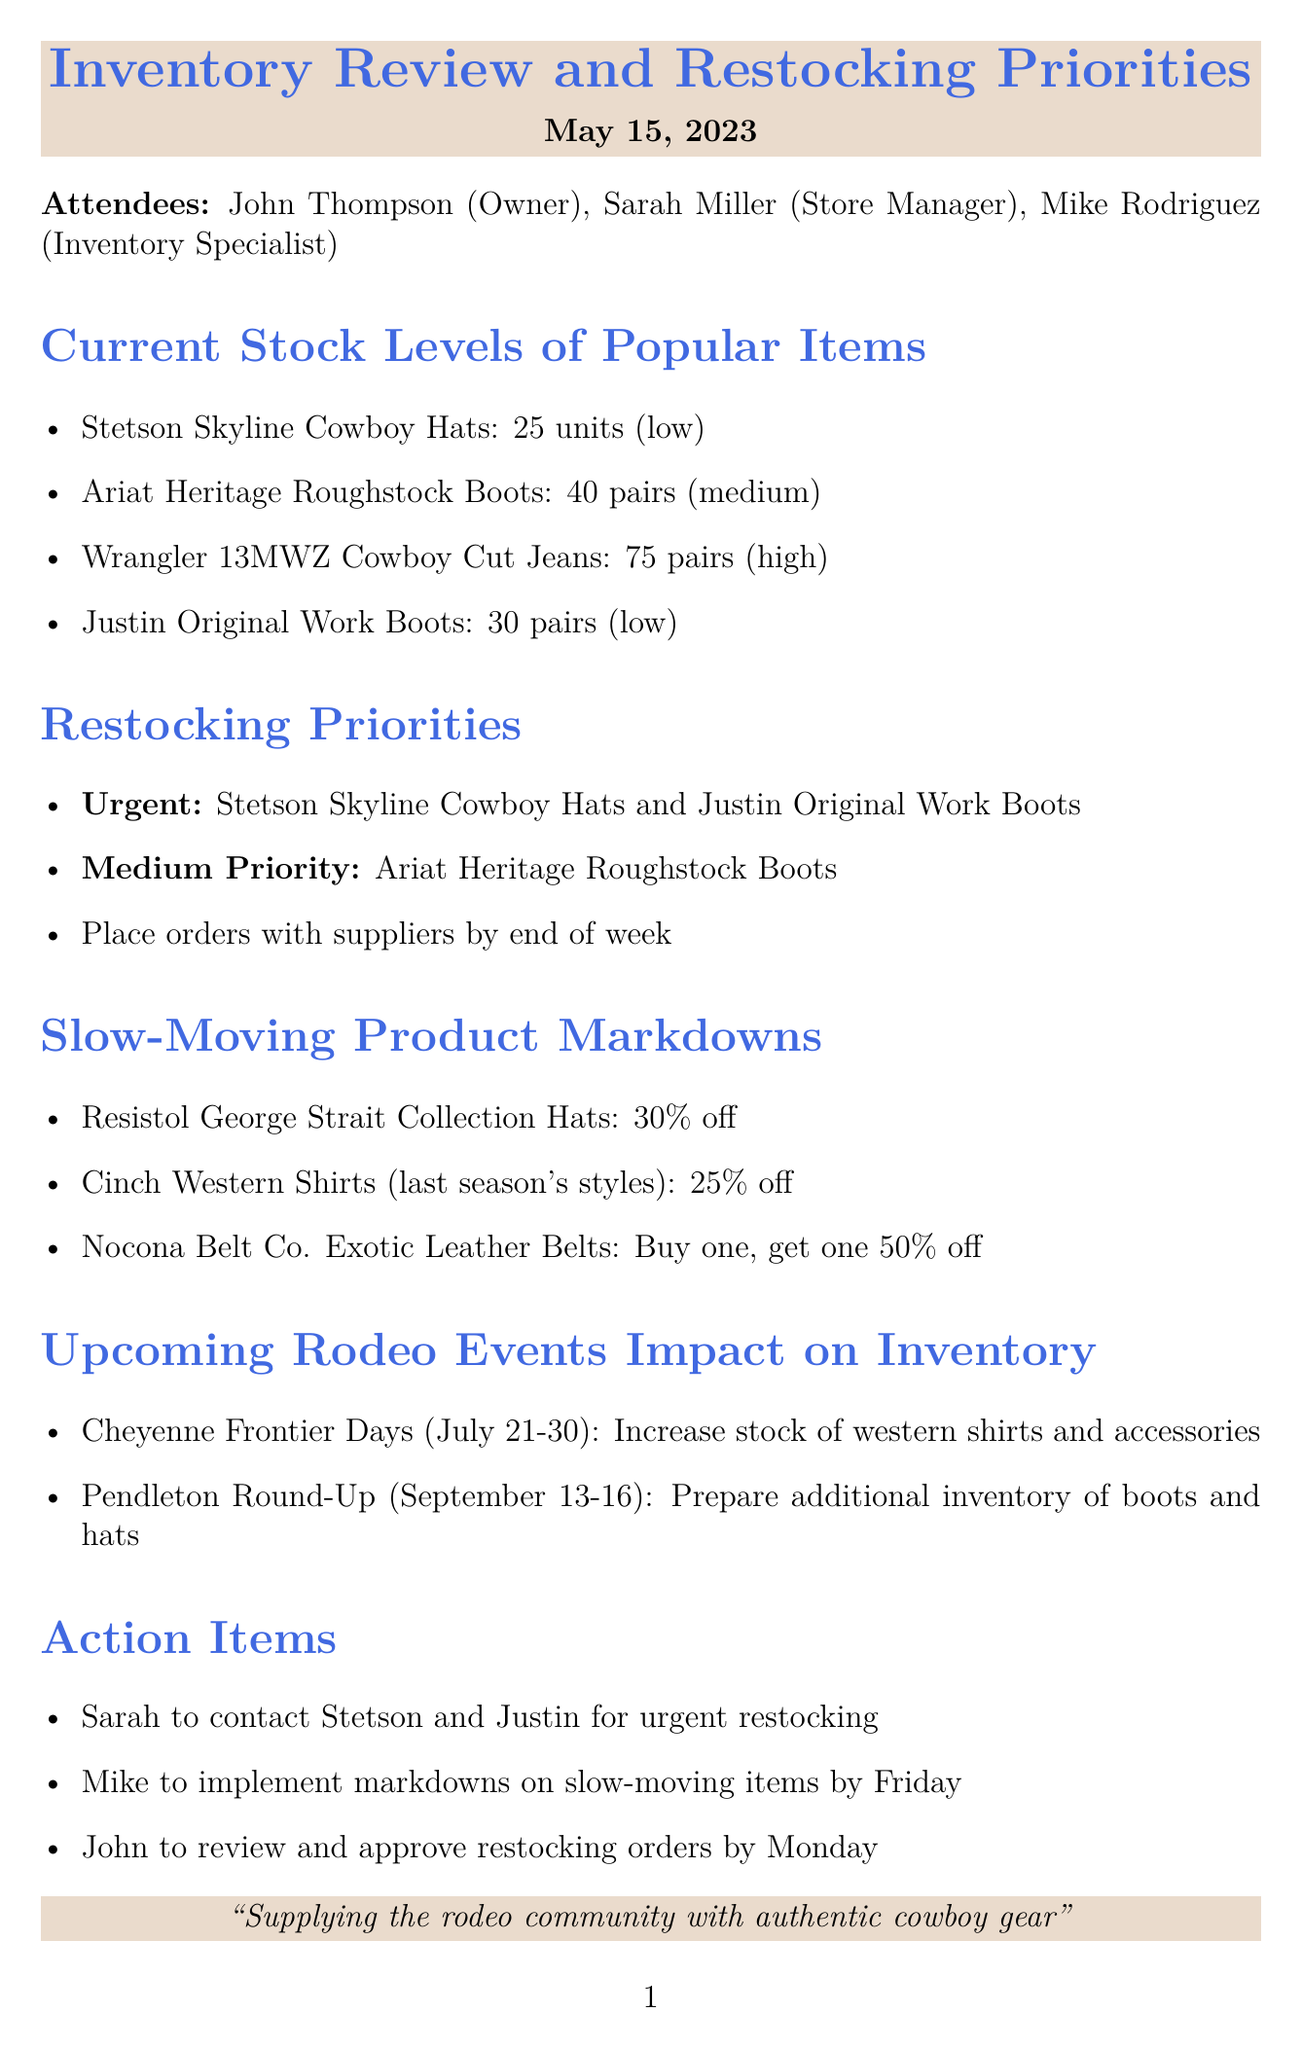What are the low stock items? The low stock items are specified in the document, which include Stetson Skyline Cowboy Hats and Justin Original Work Boots.
Answer: Stetson Skyline Cowboy Hats, Justin Original Work Boots What is the markdown percentage for Resistol George Strait Collection Hats? The markdown percentage is clearly stated for the item in the document.
Answer: 30% off What is the medium priority for restocking? The medium priority item for restocking is mentioned in the restocking priorities section of the document.
Answer: Ariat Heritage Roughstock Boots When is the Cheyenne Frontier Days event? The date for the event is provided in the document, which specifies the start and end dates.
Answer: July 21-30 Who will implement the markdowns on slow-moving items? The individual responsible for markdowns is mentioned in the action items section.
Answer: Mike What is the total number of Wrangler 13MWZ Cowboy Cut Jeans in stock? The number of Wrangler 13MWZ Cowboy Cut Jeans is provided in the current stock levels section of the document.
Answer: 75 pairs Which item is an urgent restocking priority? The document indicates which items are of urgent priority for restocking.
Answer: Stetson Skyline Cowboy Hats What will happen to Cinch Western Shirts last season's styles? The document outlines the action being taken regarding slow-moving items such as Cinch Western Shirts.
Answer: 25% off 